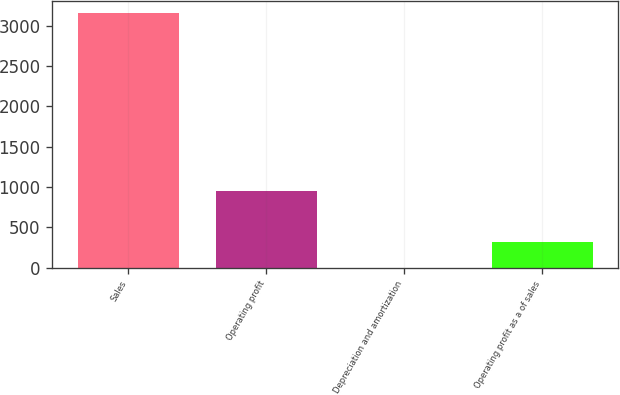<chart> <loc_0><loc_0><loc_500><loc_500><bar_chart><fcel>Sales<fcel>Operating profit<fcel>Depreciation and amortization<fcel>Operating profit as a of sales<nl><fcel>3153.4<fcel>947.42<fcel>2<fcel>317.14<nl></chart> 